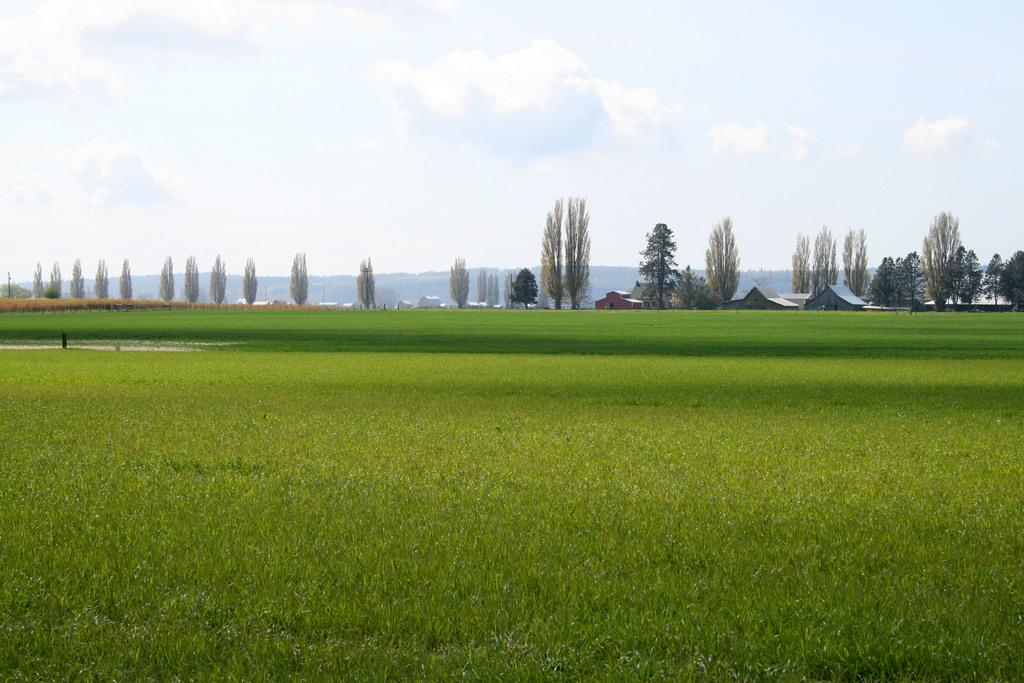What type of vegetation can be seen in the image? There is grass in the image. What type of structures are visible in the image? There are houses in the image. What other natural elements can be seen in the image? There are trees and mountains in the image. What is visible in the background of the image? The sky is visible in the background of the image. What is the condition of the sky in the image? Clouds are present in the sky. What type of scissors can be seen cutting the grass in the image? There are no scissors present in the image; the grass is not being cut. What force is being applied to the mountains in the image? There is no force being applied to the mountains in the image; they are stationary. 